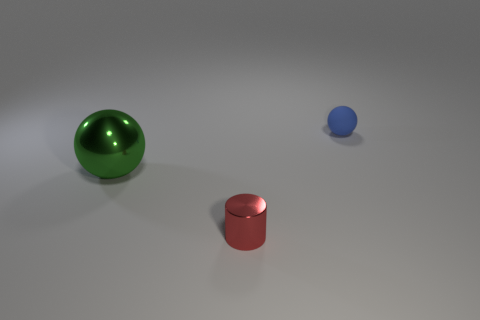What could be the purpose of these objects? These objects could be used for various purposes, such as decorative items due to their sleek appearance, or they could be part of a display for educational purposes to demonstrate geometric shapes and properties. 